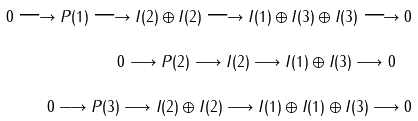Convert formula to latex. <formula><loc_0><loc_0><loc_500><loc_500>0 \longrightarrow P ( 1 ) \longrightarrow I ( 2 ) \oplus I ( 2 ) \longrightarrow I ( 1 ) \oplus I ( 3 ) \oplus I ( 3 ) \longrightarrow 0 \\ 0 \longrightarrow P ( 2 ) \longrightarrow I ( 2 ) \longrightarrow I ( 1 ) \oplus I ( 3 ) \longrightarrow 0 \quad \\ 0 \longrightarrow P ( 3 ) \longrightarrow I ( 2 ) \oplus I ( 2 ) \longrightarrow I ( 1 ) \oplus I ( 1 ) \oplus I ( 3 ) \longrightarrow 0</formula> 